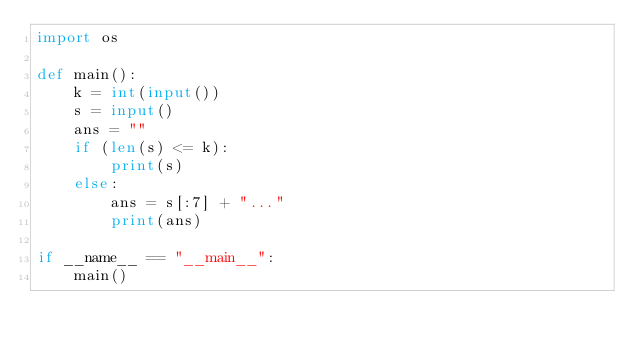Convert code to text. <code><loc_0><loc_0><loc_500><loc_500><_Python_>import os

def main():
    k = int(input())
    s = input()
    ans = ""
    if (len(s) <= k):
        print(s)
    else:
        ans = s[:7] + "..."
        print(ans)

if __name__ == "__main__":
    main()</code> 